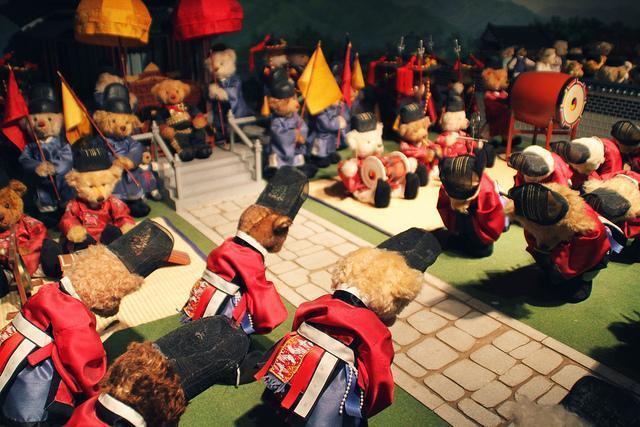How many teddy bears are visible?
Give a very brief answer. 14. 